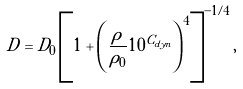Convert formula to latex. <formula><loc_0><loc_0><loc_500><loc_500>D = D _ { 0 } \left [ 1 + \left ( \frac { \rho } { \rho _ { 0 } } 1 0 ^ { C _ { d y n } } \right ) ^ { 4 } \right ] ^ { - 1 / 4 } ,</formula> 